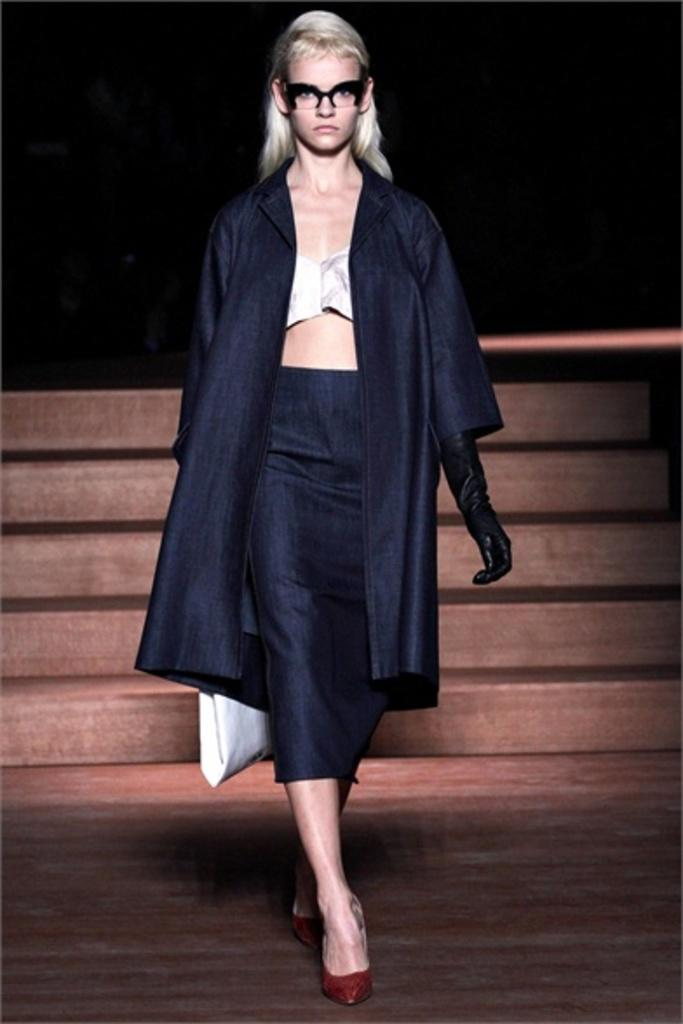Who is the main subject in the image? There is a woman in the image. What is the woman doing in the image? The woman is walking. Can you describe the woman's appearance? The woman is wearing spectacles. What type of surface is visible in the image? There is a floor visible in the image. Are there any architectural features in the image? Yes, there are stairs in the image. What is the lighting condition in the image? The background of the image is dark. What type of fish can be seen swimming in the background of the image? There are no fish present in the image; the background is dark, and the focus is on the woman walking. Can you hear the sound of bells ringing in the image? There is no auditory information provided in the image, so it is not possible to determine if bells are ringing. 